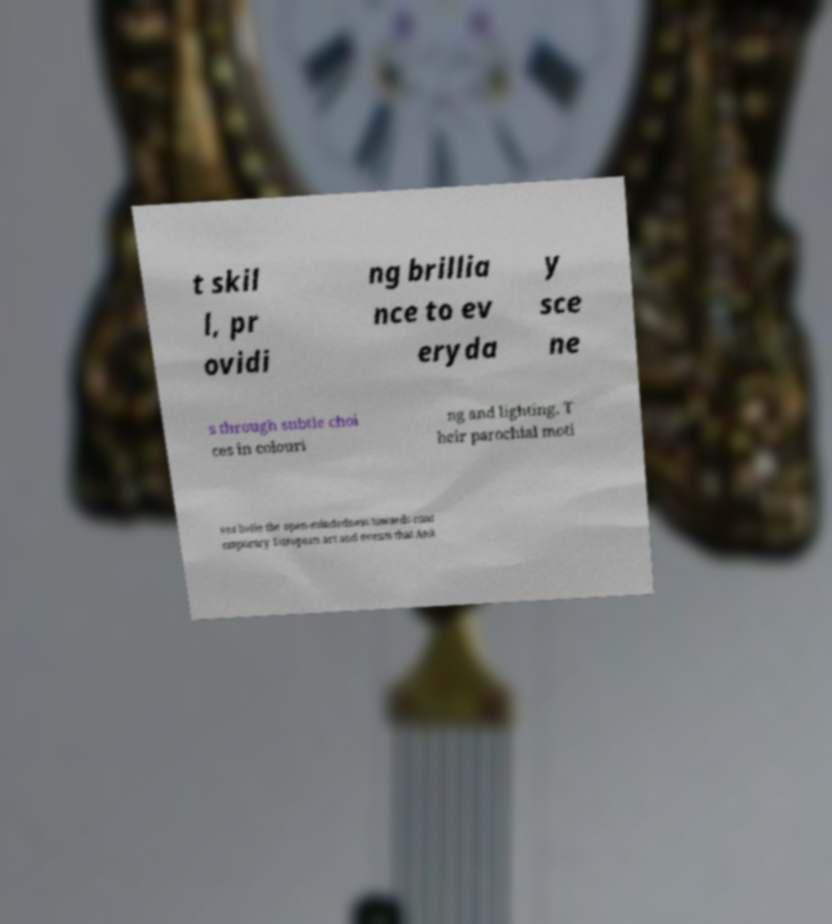Could you extract and type out the text from this image? t skil l, pr ovidi ng brillia nce to ev eryda y sce ne s through subtle choi ces in colouri ng and lighting. T heir parochial moti ves belie the open-mindedness towards cont emporary European art and events that Ank 